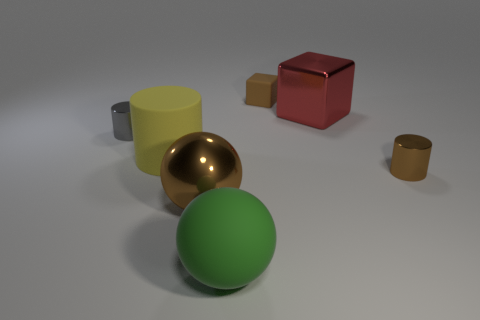Subtract all small metallic cylinders. How many cylinders are left? 1 Add 2 brown rubber cubes. How many objects exist? 9 Subtract 1 cylinders. How many cylinders are left? 2 Subtract all brown cylinders. How many cylinders are left? 2 Subtract all gray cylinders. Subtract all gray balls. How many cylinders are left? 2 Subtract all cyan spheres. How many red blocks are left? 1 Subtract all yellow shiny spheres. Subtract all big yellow objects. How many objects are left? 6 Add 7 blocks. How many blocks are left? 9 Add 7 large brown cubes. How many large brown cubes exist? 7 Subtract 0 green cylinders. How many objects are left? 7 